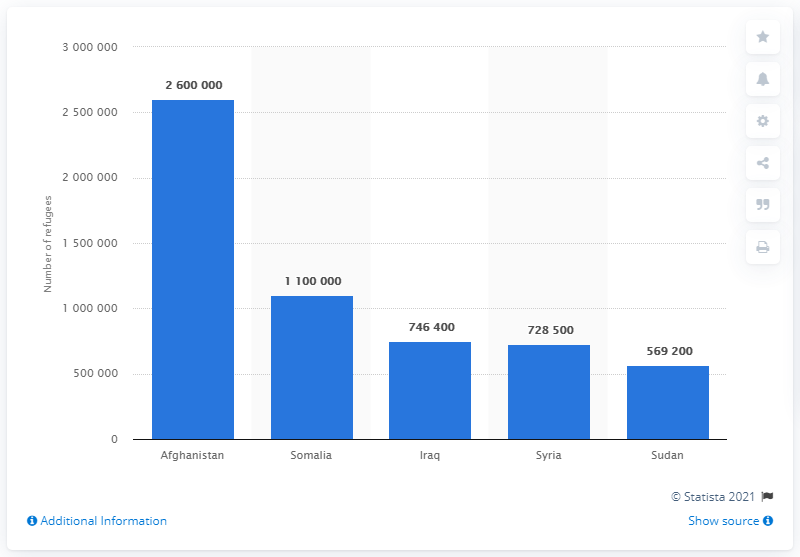Draw attention to some important aspects in this diagram. In 2013, approximately 260,000 refugees came from Afghanistan. 